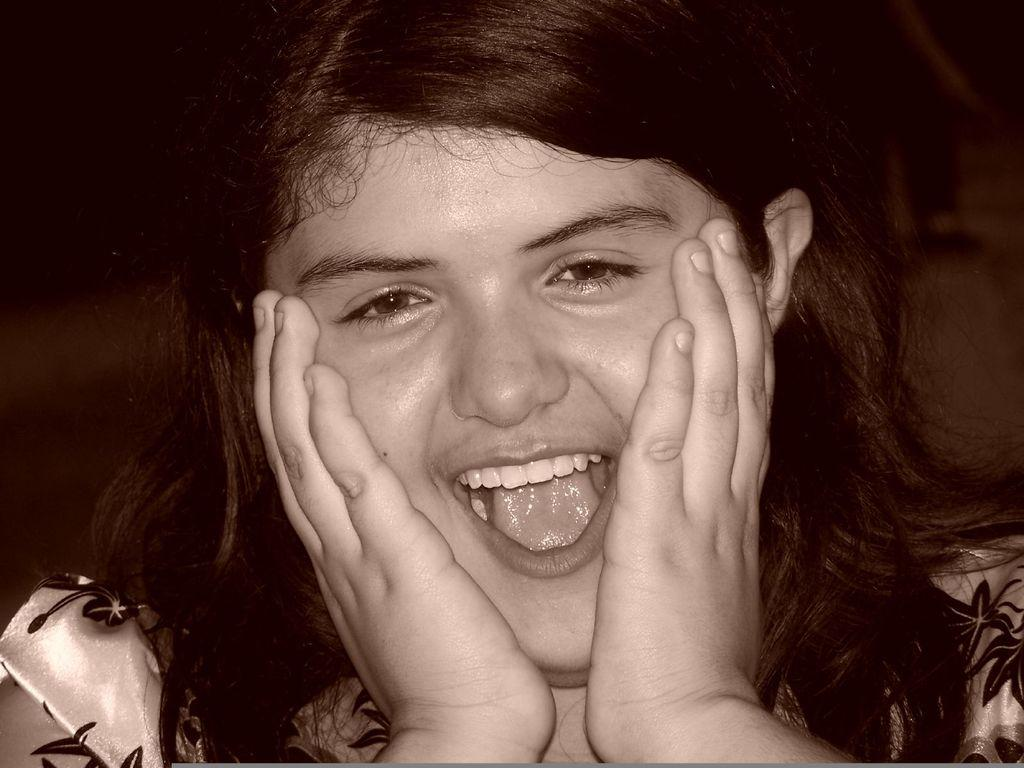Who is in the picture? There is a woman in the picture. What is the woman doing in the picture? The woman is smiling in the picture. Can you describe the background of the image? The background of the image is blurred. What type of writing can be seen on the woman's shirt in the image? There is no writing visible on the woman's shirt in the image. What color is the paint on the coach in the image? There is no coach or paint present in the image. 